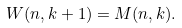<formula> <loc_0><loc_0><loc_500><loc_500>W ( n , k + 1 ) = M ( n , k ) .</formula> 